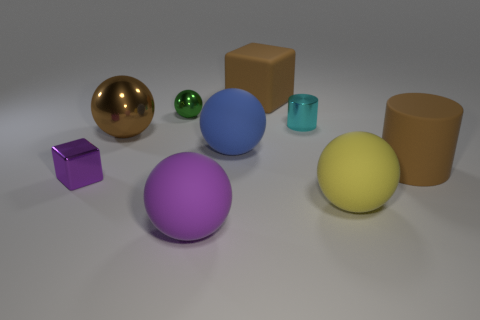Subtract all big yellow spheres. How many spheres are left? 4 Subtract 1 blocks. How many blocks are left? 1 Subtract all brown cylinders. Subtract all purple spheres. How many cylinders are left? 1 Subtract all yellow cylinders. How many purple blocks are left? 1 Subtract all green shiny spheres. Subtract all large brown things. How many objects are left? 5 Add 7 cyan metal cylinders. How many cyan metal cylinders are left? 8 Add 6 large brown metal balls. How many large brown metal balls exist? 7 Add 1 green objects. How many objects exist? 10 Subtract all purple spheres. How many spheres are left? 4 Subtract 1 brown spheres. How many objects are left? 8 